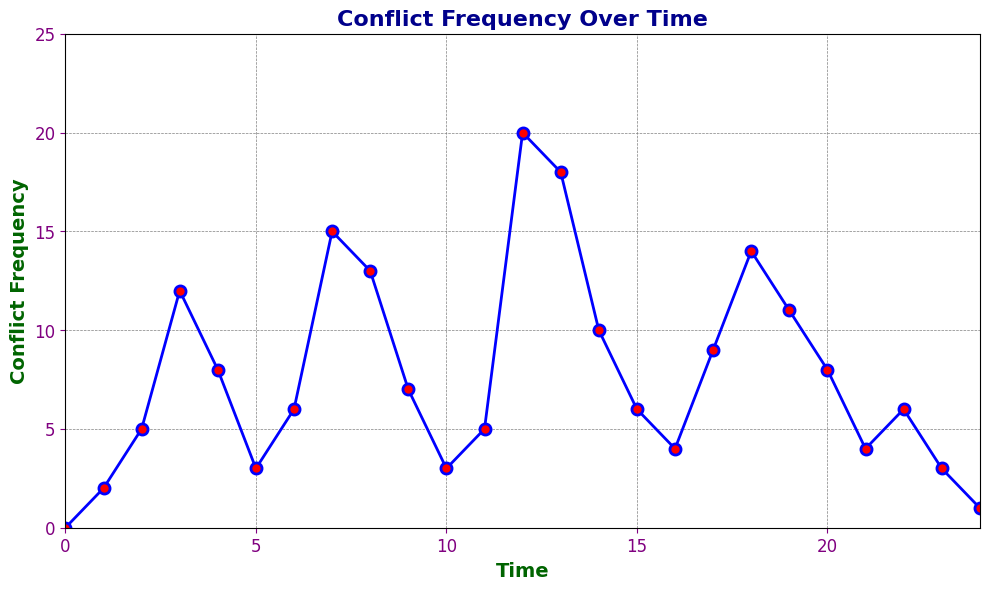When is the first peak in the conflict frequency observed? The first peak is observed at the highest point before any notable drops in the graph. Looking at the graph, the first major peak occurs at Time = 3.
Answer: 3 Which time point has the highest conflict frequency? The highest conflict frequency will be the tallest point on the graph. The highest point is observed at Time = 12.
Answer: 12 What is the difference in conflict frequency between Time = 7 and Time = 9? The conflict frequency at Time = 7 is 15 and at Time = 9 is 7. The difference between them is 15 - 7 = 8.
Answer: 8 What is the average conflict frequency over the time period from Time = 0 to Time = 24? To calculate the average, sum up all the conflict frequencies and divide by the number of time points. There are 25 time points. Sum = 0+2+5+12+8+3+6+15+13+7+3+5+20+18+10+6+4+9+14+11+8+4+6+3+1 = 191. Average = 191/25 ≈ 7.64
Answer: 7.64 Between which two time points does the conflict frequency show the largest drop? To identify the largest drop, observe the graph for the steepest decline. The largest drop is between Time = 3 (frequency 12) and Time = 5 (frequency 3) where the frequency drops by 9.
Answer: 3 and 5 What trend do you observe in the conflict frequency from Time = 8 to Time = 12? The conflict frequency shows an increasing trend from Time = 8 (frequency 13) to its peak at Time = 12 (frequency 20).
Answer: Increasing Is there any time where the conflict frequency remained the same for two consecutive periods? By looking at continuous points, we see that there are no two consecutive time points with the same conflict frequency.
Answer: No At what time is the conflict frequency exactly 10? By examining the graph or the data table, the conflict frequency is exactly 10 at Time = 14.
Answer: 14 Between Time = 0 and Time = 12, how many times did the conflict frequency increase compared to the previous time point? Compare each point to the previous one within the given range. Count the number of increases: 2 (T1), 5 (T2), 12 (T3), 8 (T4), 6 (T6), 15 (T7), 13 (T8), and 20 (T12). There are 7 increases.
Answer: 7 